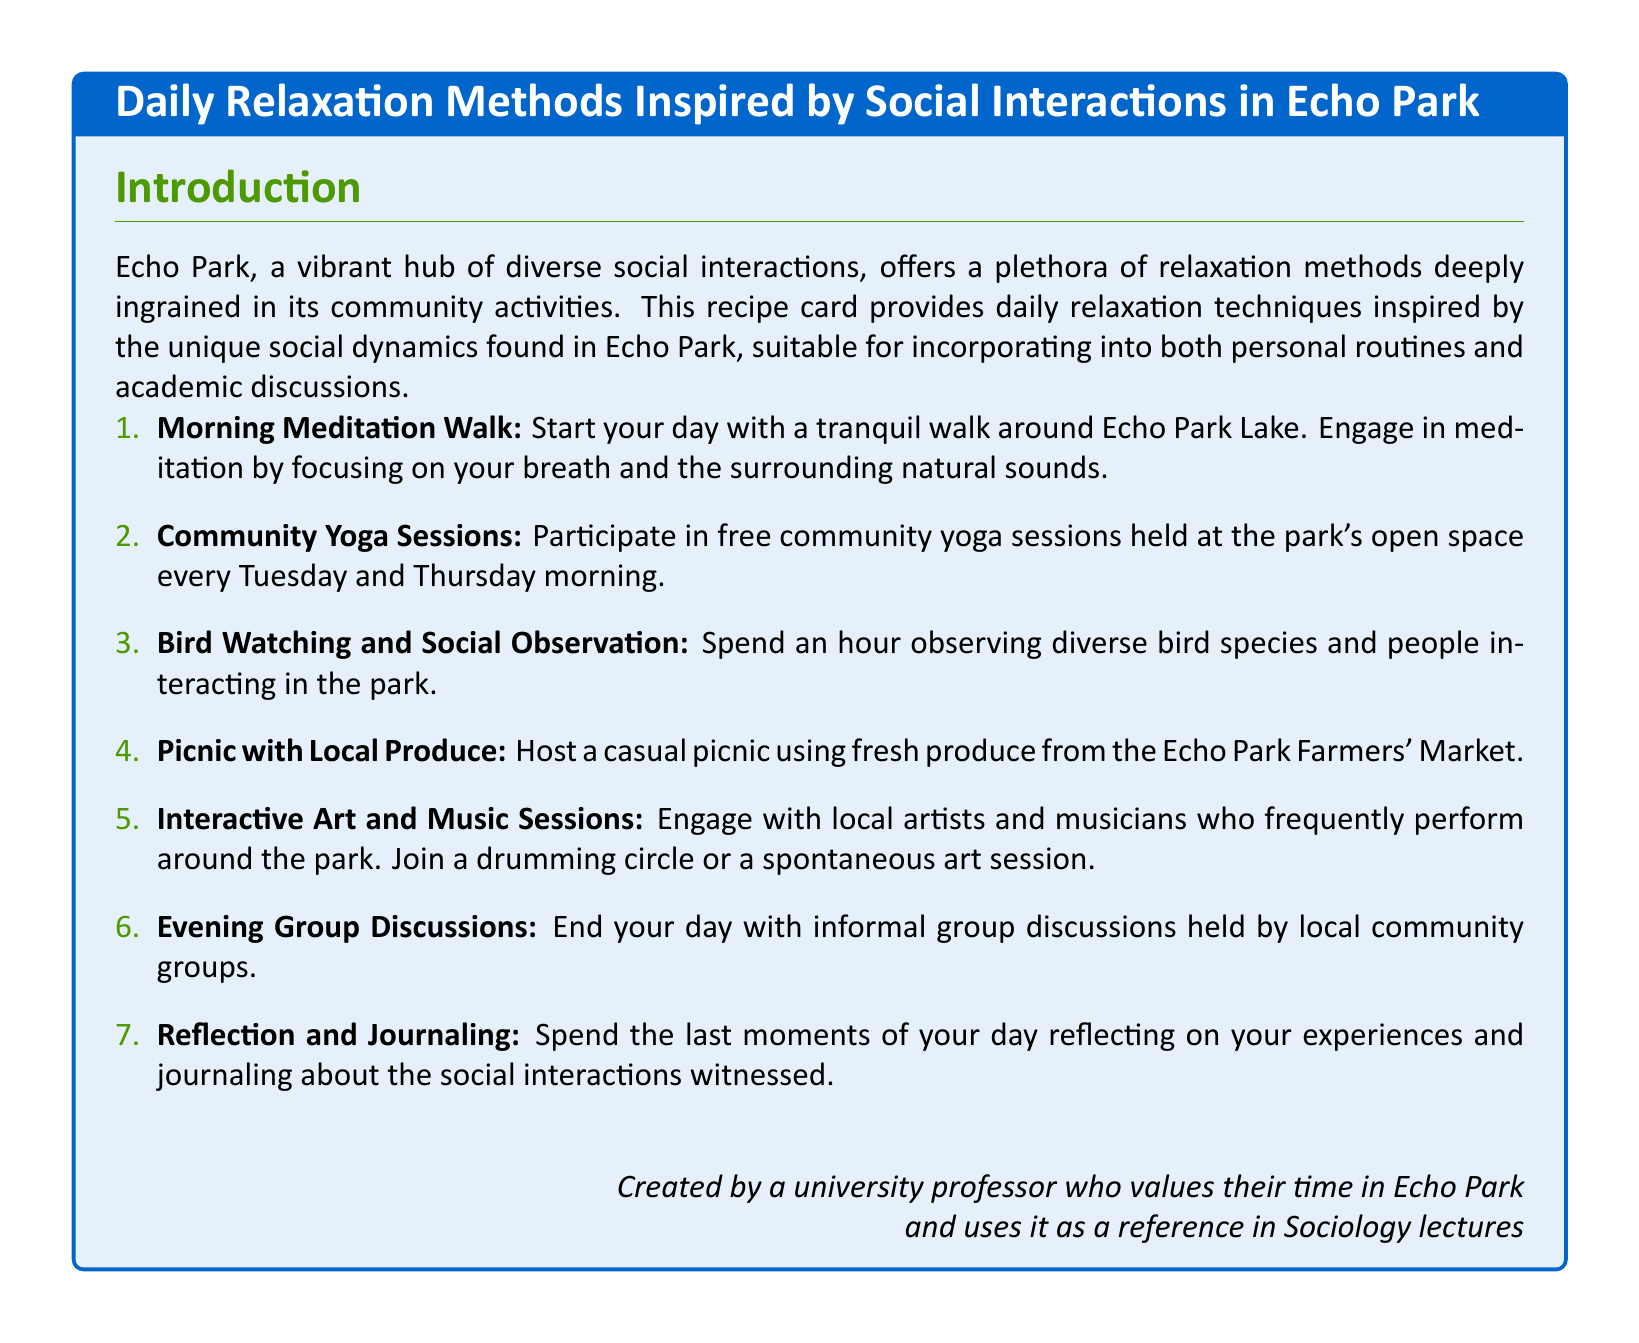What is the title of the document? The title of the document is prominently displayed at the top of the tcolorbox.
Answer: Daily Relaxation Methods Inspired by Social Interactions in Echo Park How many relaxation methods are listed? The number of relaxation methods can be found by counting the items in the enumeration.
Answer: 7 On which days are community yoga sessions held? The document specifies the days of the week when these sessions occur.
Answer: Tuesday and Thursday What activity involves observing bird species? The activity mentioned incorporates interaction with nature and observation.
Answer: Bird Watching and Social Observation What can you host a picnic with? The document specifies the type of products to be used for the picnic.
Answer: Local Produce What is the last activity mentioned in the list? The last activity mentioned provides a reflective technique at the end of the day.
Answer: Reflection and Journaling What is the purpose of the document? The document serves to provide relaxation techniques inspired by community interaction.
Answer: Daily relaxation techniques 